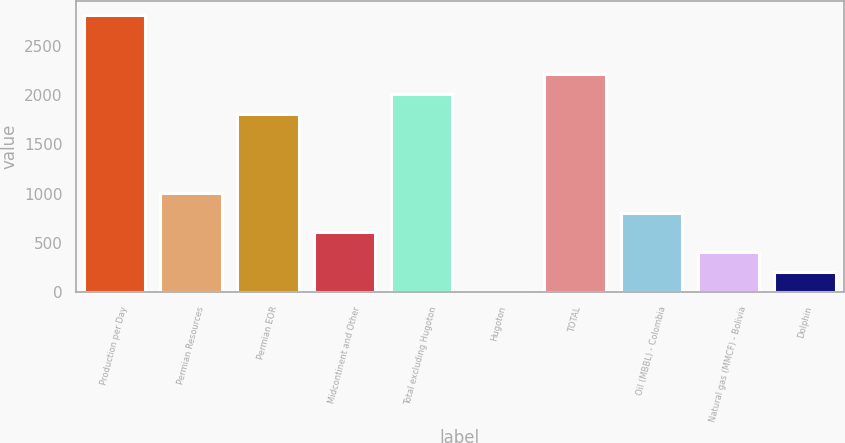Convert chart. <chart><loc_0><loc_0><loc_500><loc_500><bar_chart><fcel>Production per Day<fcel>Permian Resources<fcel>Permian EOR<fcel>Midcontinent and Other<fcel>Total excluding Hugoton<fcel>Hugoton<fcel>TOTAL<fcel>Oil (MBBL) - Colombia<fcel>Natural gas (MMCF) - Bolivia<fcel>Dolphin<nl><fcel>2815.8<fcel>1009.5<fcel>1812.3<fcel>608.1<fcel>2013<fcel>6<fcel>2213.7<fcel>808.8<fcel>407.4<fcel>206.7<nl></chart> 